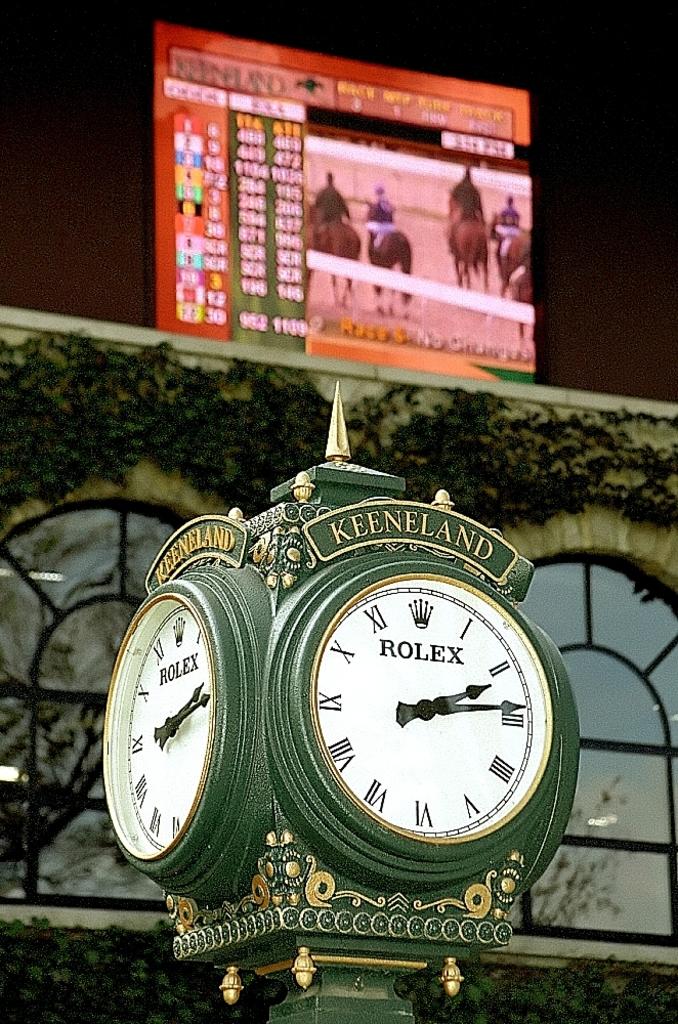Is keeneland a horse racing track?
Your response must be concise. Yes. 